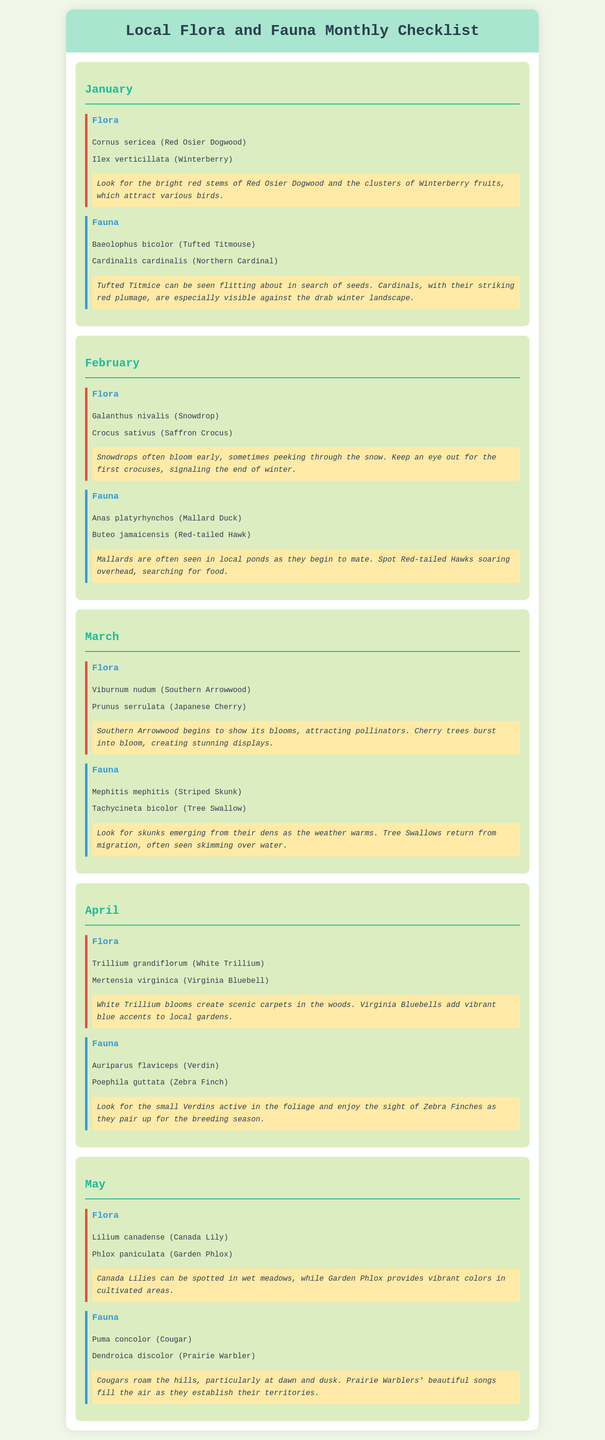what flora is listed for January? The flora section for January includes the species Cornus sericea and Ilex verticillata.
Answer: Cornus sericea, Ilex verticillata which fauna can be spotted in February? The fauna for February lists Anas platyrhynchos and Buteo jamaicensis.
Answer: Anas platyrhynchos, Buteo jamaicensis how many unique flora species are mentioned in March? In March, there are two unique flora species listed: Viburnum nudum and Prunus serrulata.
Answer: 2 what does the January notes mention about the Winterberry? The notes for January highlight that Winterberry attracts various birds.
Answer: Attracts various birds which month features the Canada Lily? The species Lilium canadense, commonly known as Canada Lily, is mentioned in May.
Answer: May which faunal species is noted for vocalizing in May? The document states that Dendroica discolor, or Prairie Warbler, fills the air with songs in May.
Answer: Prairie Warbler what key visual feature is noted for the Red Osier Dogwood? The Red Osier Dogwood is highlighted for its bright red stems.
Answer: Bright red stems what general change does the arrival of the Tree Swallows in March signify? The return of Tree Swallows in March indicates the warming weather and the start of their migration back.
Answer: Warming weather 